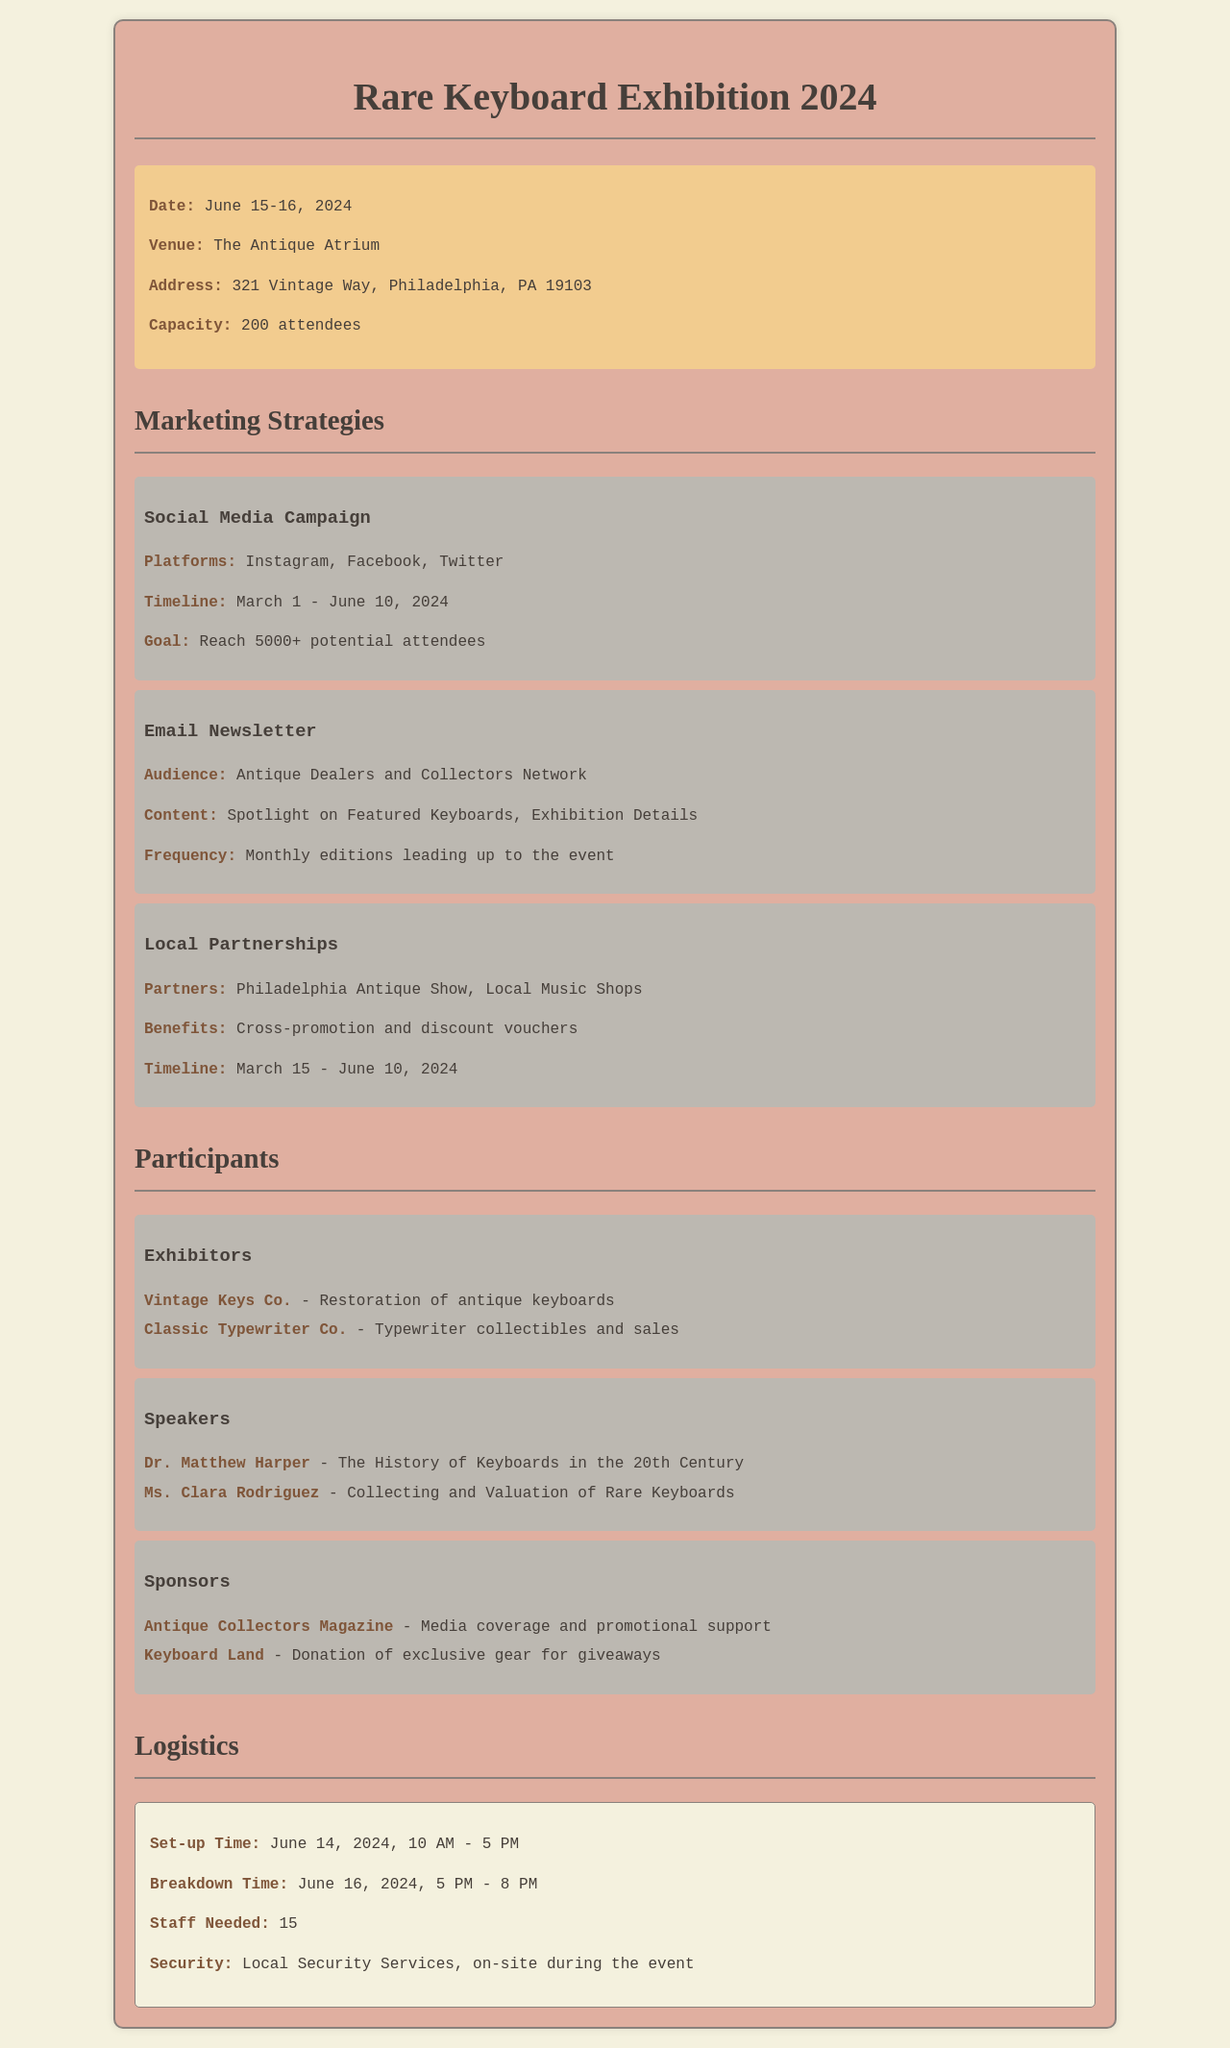What are the exhibition dates? The exhibition dates are provided in the event details section, indicating when the event takes place.
Answer: June 15-16, 2024 What is the venue of the exhibition? The document specifies the venue where the event will be held.
Answer: The Antique Atrium How many attendees can the venue accommodate? The capacity of the venue is mentioned, indicating how many people can attend.
Answer: 200 attendees What is the goal of the social media campaign? The goal of the social media campaign is highlighted under the marketing strategies section, indicating what is targeted through the campaign.
Answer: Reach 5000+ potential attendees Who is speaking about keyboard valuation? The document lists speakers under the participants section, providing names and topics they will cover.
Answer: Ms. Clara Rodriguez What is the set-up time for the event? The logistics section details the time allocated for event set-up.
Answer: June 14, 2024, 10 AM - 5 PM Which entity is providing media coverage? The sponsors section identifies a participant providing media support for the event.
Answer: Antique Collectors Magazine What is the breakdown time for the event? The logistics section provides details on when the event will conclude and when breakdown occurs.
Answer: June 16, 2024, 5 PM - 8 PM 